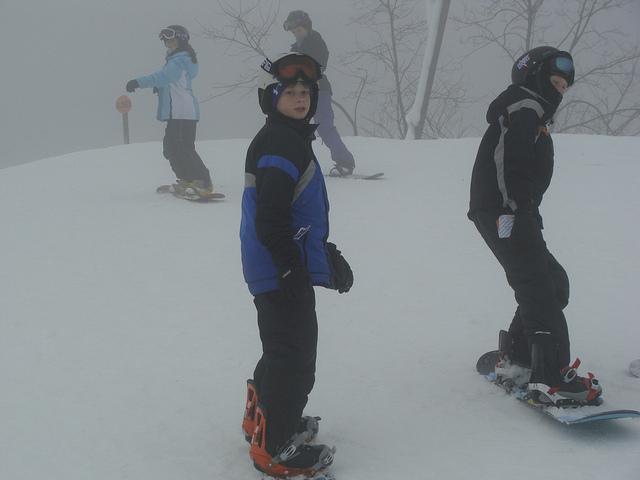What are the people doing?
Write a very short answer. Snowboarding. How many people are in the image?
Be succinct. 4. Is a cold day?
Concise answer only. Yes. 